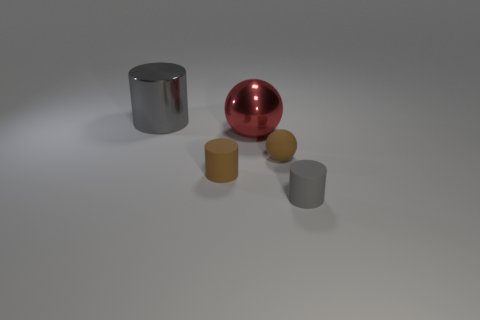What time of day does the setting suggest in the image? The image appears to be artificially lit rather than having natural daylight, which could suggest an indoor setting under controlled lighting conditions at any time of day. The shadows are soft and diffuse, indicating multiple light sources without a strong directional influence, as would be the case with sunlight. 